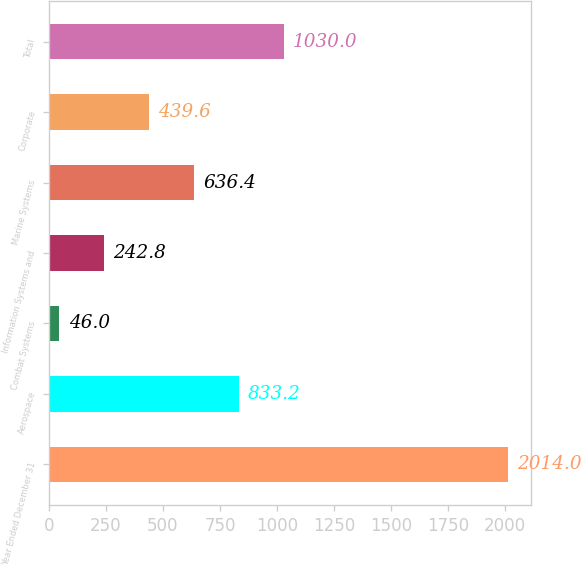Convert chart. <chart><loc_0><loc_0><loc_500><loc_500><bar_chart><fcel>Year Ended December 31<fcel>Aerospace<fcel>Combat Systems<fcel>Information Systems and<fcel>Marine Systems<fcel>Corporate<fcel>Total<nl><fcel>2014<fcel>833.2<fcel>46<fcel>242.8<fcel>636.4<fcel>439.6<fcel>1030<nl></chart> 